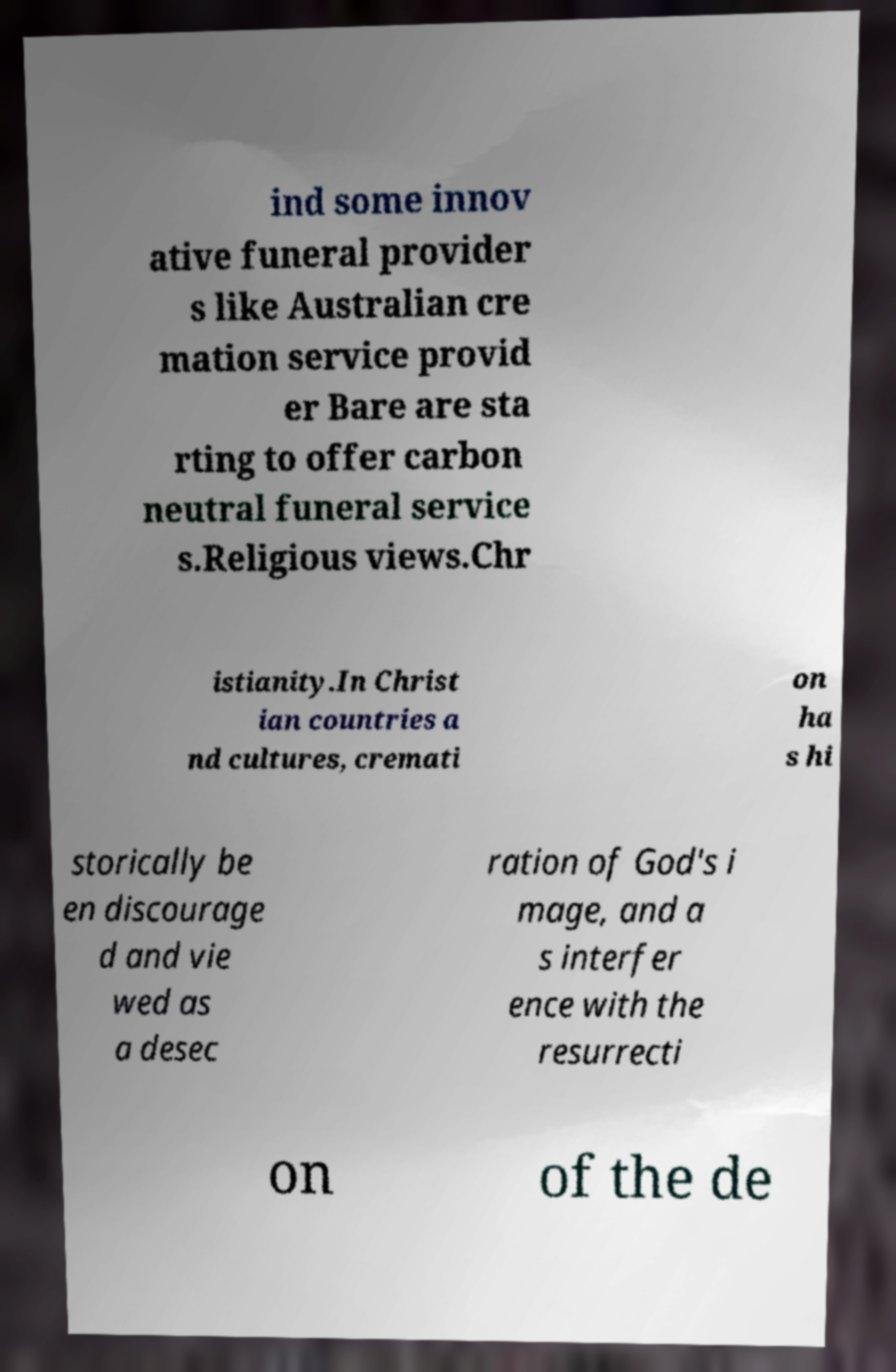Please identify and transcribe the text found in this image. ind some innov ative funeral provider s like Australian cre mation service provid er Bare are sta rting to offer carbon neutral funeral service s.Religious views.Chr istianity.In Christ ian countries a nd cultures, cremati on ha s hi storically be en discourage d and vie wed as a desec ration of God's i mage, and a s interfer ence with the resurrecti on of the de 